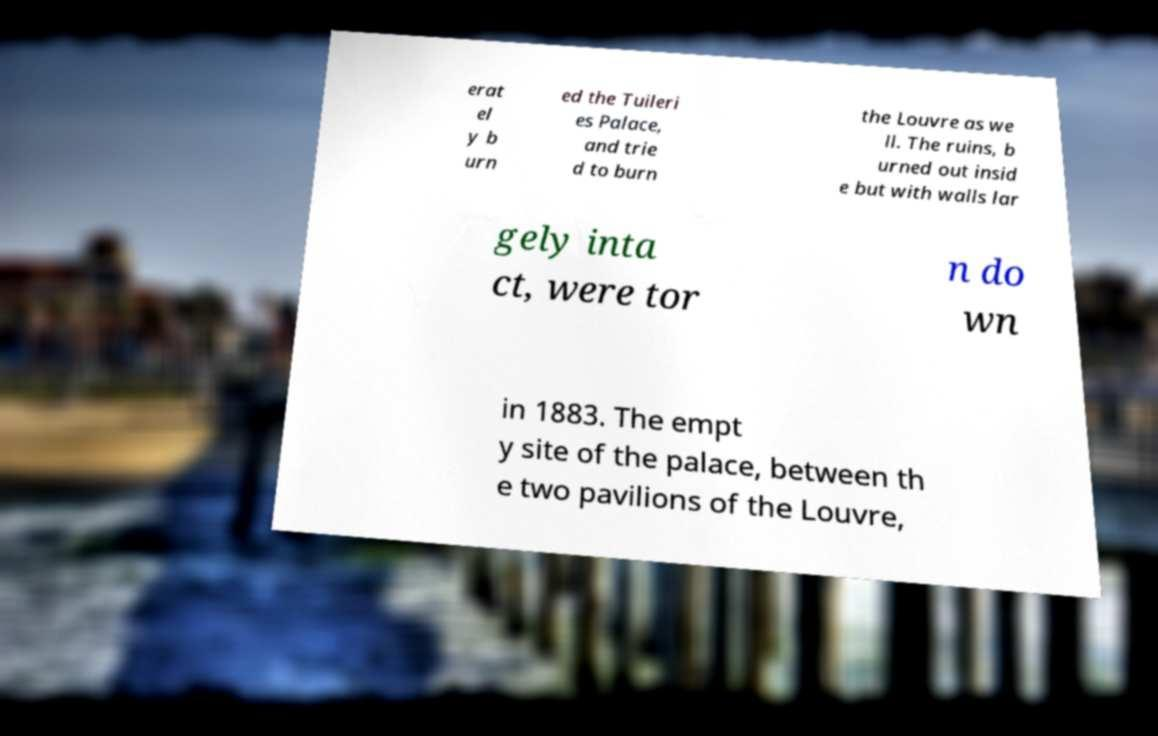For documentation purposes, I need the text within this image transcribed. Could you provide that? erat el y b urn ed the Tuileri es Palace, and trie d to burn the Louvre as we ll. The ruins, b urned out insid e but with walls lar gely inta ct, were tor n do wn in 1883. The empt y site of the palace, between th e two pavilions of the Louvre, 